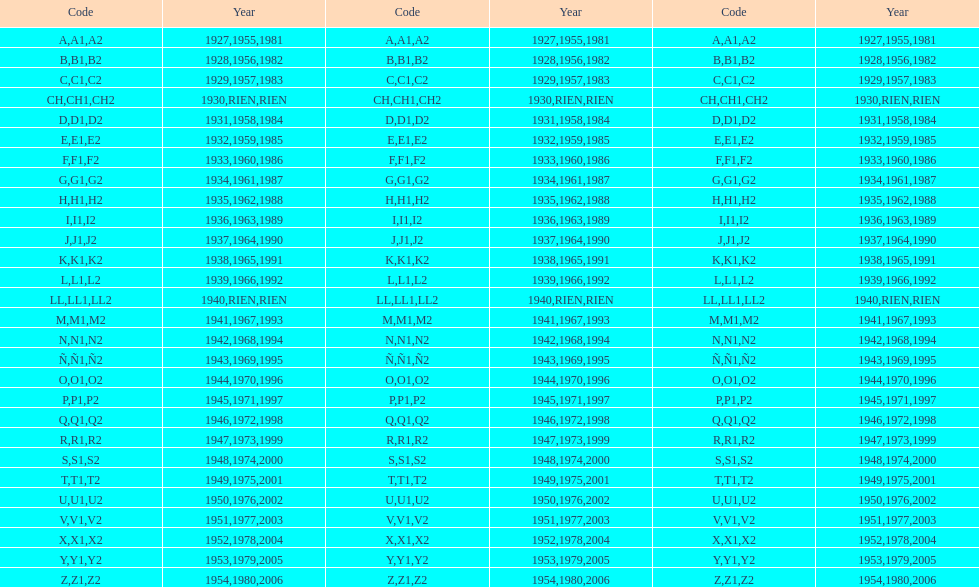In which year was the lowest stamp issued? 1927. 